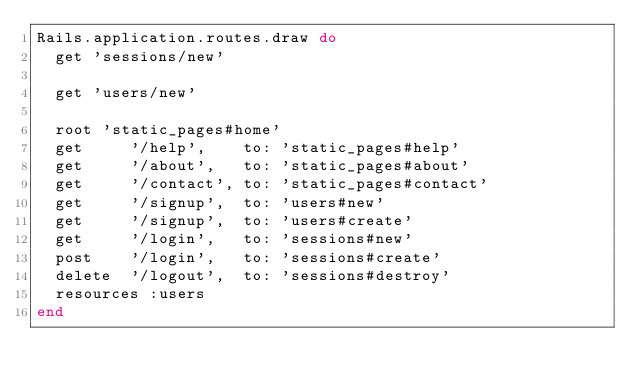Convert code to text. <code><loc_0><loc_0><loc_500><loc_500><_Ruby_>Rails.application.routes.draw do
  get 'sessions/new'

  get 'users/new'

  root 'static_pages#home'
  get     '/help',    to: 'static_pages#help'
  get     '/about',   to: 'static_pages#about'
  get     '/contact', to: 'static_pages#contact'
  get     '/signup',  to: 'users#new'
  get     '/signup',  to: 'users#create'
  get     '/login',   to: 'sessions#new'
  post    '/login',   to: 'sessions#create'
  delete  '/logout',  to: 'sessions#destroy'
  resources :users
end
</code> 